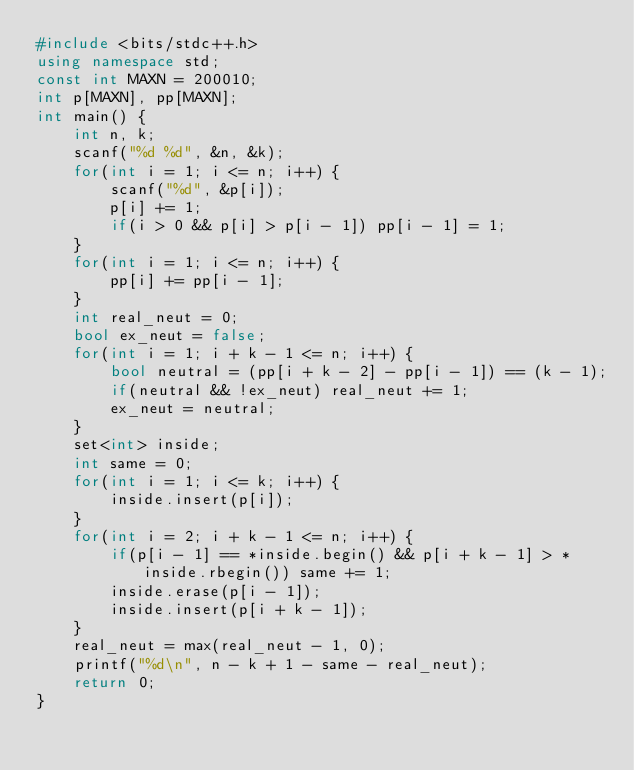<code> <loc_0><loc_0><loc_500><loc_500><_C++_>#include <bits/stdc++.h>
using namespace std;
const int MAXN = 200010;
int p[MAXN], pp[MAXN];
int main() {
    int n, k;
    scanf("%d %d", &n, &k);
    for(int i = 1; i <= n; i++) {
        scanf("%d", &p[i]);
        p[i] += 1;
        if(i > 0 && p[i] > p[i - 1]) pp[i - 1] = 1;
    }
    for(int i = 1; i <= n; i++) {
        pp[i] += pp[i - 1];
    }
    int real_neut = 0;
    bool ex_neut = false;
    for(int i = 1; i + k - 1 <= n; i++) {
        bool neutral = (pp[i + k - 2] - pp[i - 1]) == (k - 1);
        if(neutral && !ex_neut) real_neut += 1;
        ex_neut = neutral; 
    }
    set<int> inside;
    int same = 0;
    for(int i = 1; i <= k; i++) {
        inside.insert(p[i]);
    }
    for(int i = 2; i + k - 1 <= n; i++) {
        if(p[i - 1] == *inside.begin() && p[i + k - 1] > *inside.rbegin()) same += 1;
        inside.erase(p[i - 1]);
        inside.insert(p[i + k - 1]);
    }
    real_neut = max(real_neut - 1, 0);
    printf("%d\n", n - k + 1 - same - real_neut);
    return 0;
}</code> 